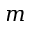Convert formula to latex. <formula><loc_0><loc_0><loc_500><loc_500>m</formula> 